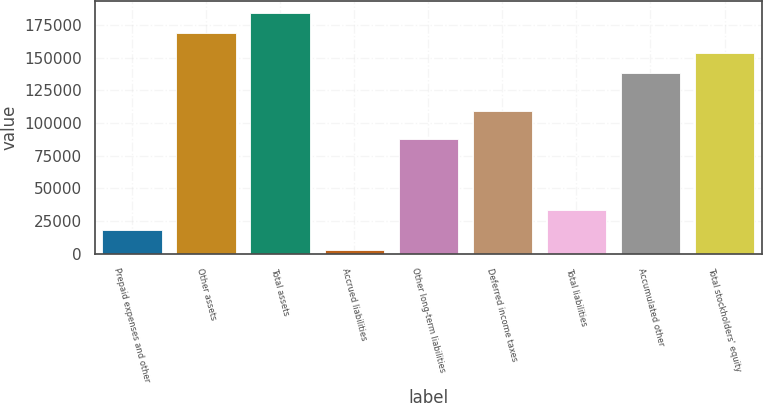Convert chart to OTSL. <chart><loc_0><loc_0><loc_500><loc_500><bar_chart><fcel>Prepaid expenses and other<fcel>Other assets<fcel>Total assets<fcel>Accrued liabilities<fcel>Other long-term liabilities<fcel>Deferred income taxes<fcel>Total liabilities<fcel>Accumulated other<fcel>Total stockholders' equity<nl><fcel>18371.5<fcel>168633<fcel>183964<fcel>3041<fcel>87770<fcel>109185<fcel>33702<fcel>137972<fcel>153302<nl></chart> 